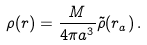<formula> <loc_0><loc_0><loc_500><loc_500>\rho ( r ) = \frac { M } { 4 \pi a ^ { 3 } } \tilde { \rho } ( r _ { a } ) \, .</formula> 